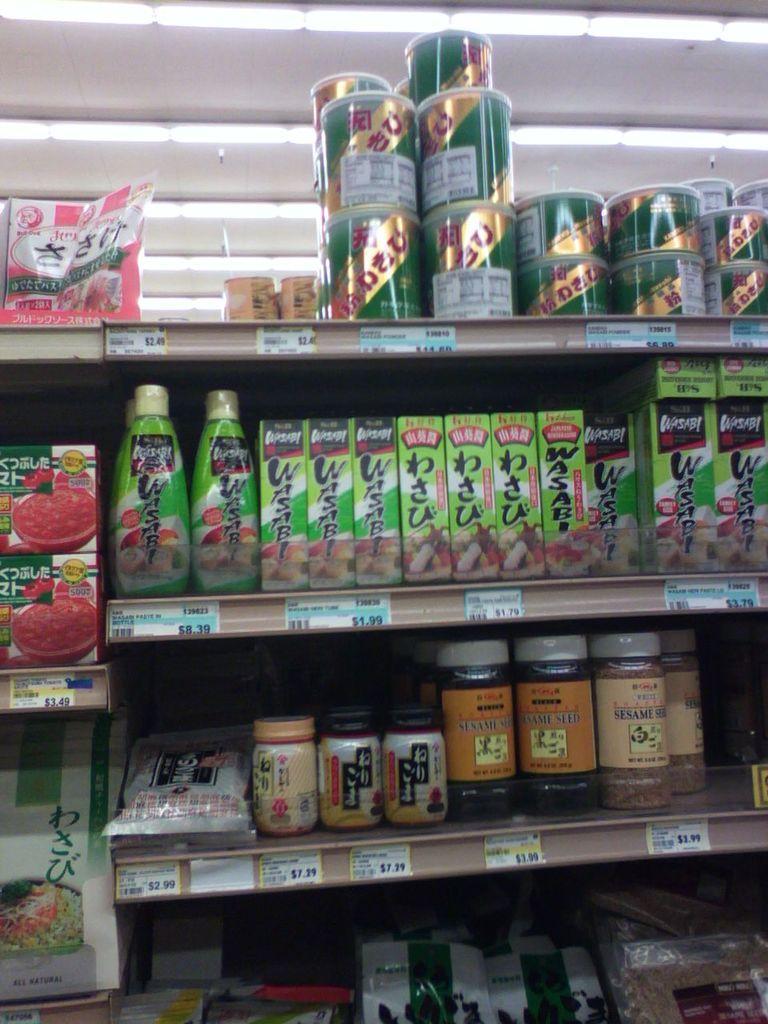Describe this image in one or two sentences. In this picture we can see shelves, here we can see bottles, jars, price tags and some objects and in the background we can see a roof. 